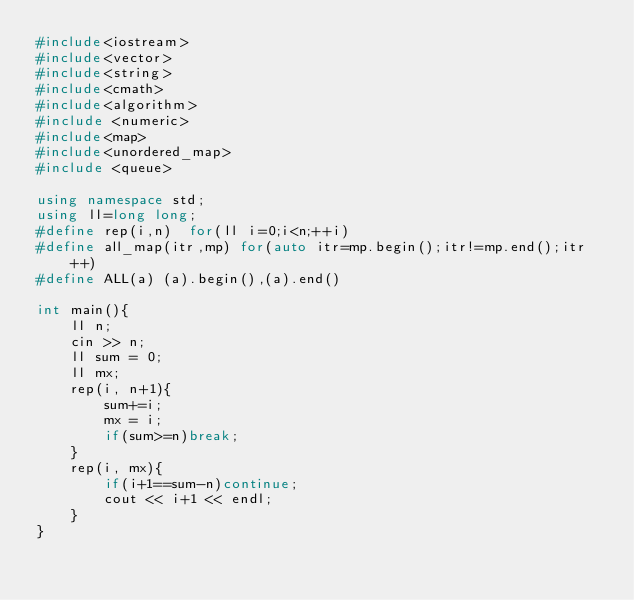<code> <loc_0><loc_0><loc_500><loc_500><_C++_>#include<iostream>
#include<vector>
#include<string>
#include<cmath>
#include<algorithm>
#include <numeric>
#include<map>
#include<unordered_map>
#include <queue>
 
using namespace std;
using ll=long long;
#define rep(i,n)  for(ll i=0;i<n;++i)
#define all_map(itr,mp) for(auto itr=mp.begin();itr!=mp.end();itr++)
#define ALL(a) (a).begin(),(a).end()
 
int main(){
    ll n;
    cin >> n;
    ll sum = 0;
    ll mx;
    rep(i, n+1){
        sum+=i;
        mx = i;
        if(sum>=n)break;
    }
    rep(i, mx){
        if(i+1==sum-n)continue;
        cout << i+1 << endl;
    }
}</code> 